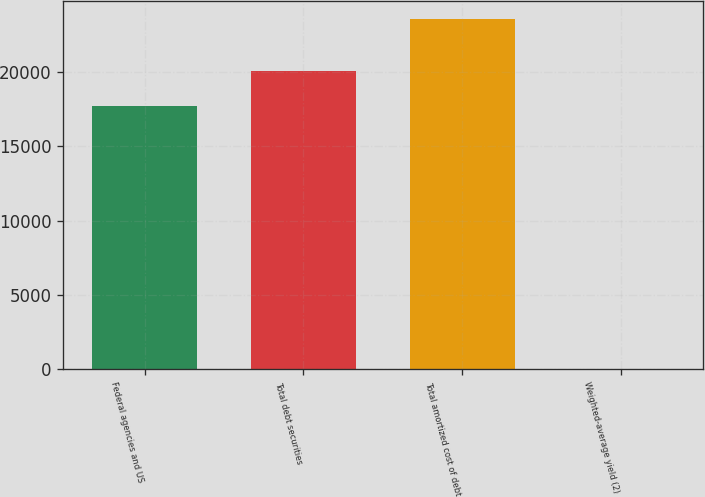Convert chart to OTSL. <chart><loc_0><loc_0><loc_500><loc_500><bar_chart><fcel>Federal agencies and US<fcel>Total debt securities<fcel>Total amortized cost of debt<fcel>Weighted-average yield (2)<nl><fcel>17683<fcel>20038.6<fcel>23559<fcel>2.65<nl></chart> 